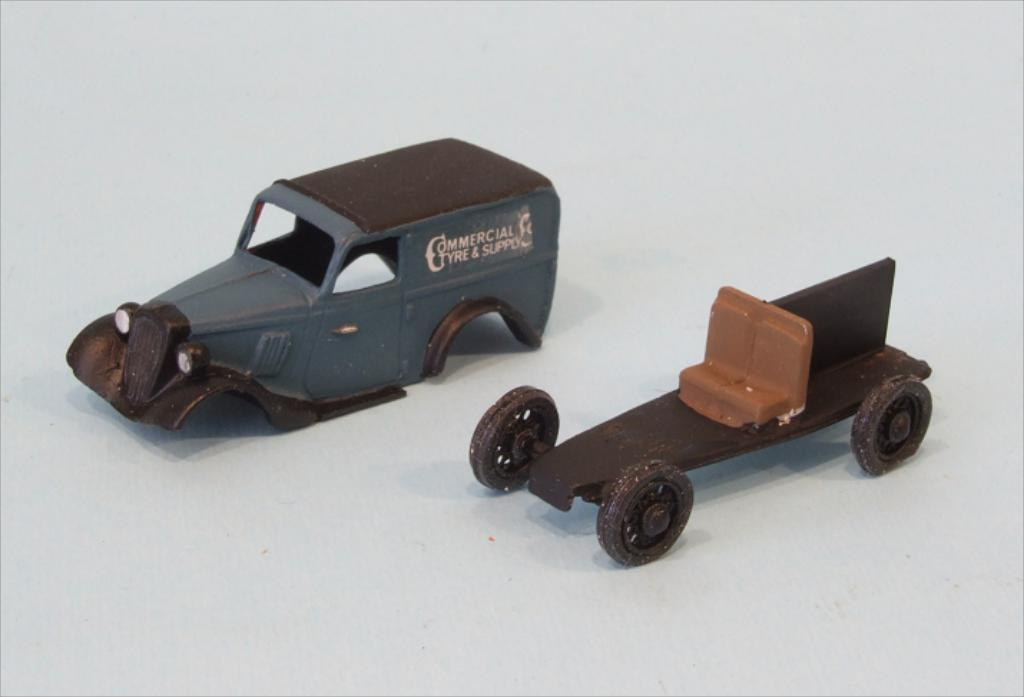What type of objects can be seen in the image? There are toys in the image. Can you hear the bells ringing in the image? There are no bells present in the image, so it is not possible to hear them ringing. 